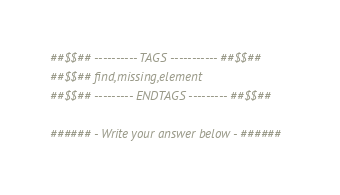<code> <loc_0><loc_0><loc_500><loc_500><_Python_>##$$## ---------- TAGS ----------- ##$$##
##$$## find,missing,element
##$$## --------- ENDTAGS --------- ##$$##

###### - Write your answer below - ######
</code> 